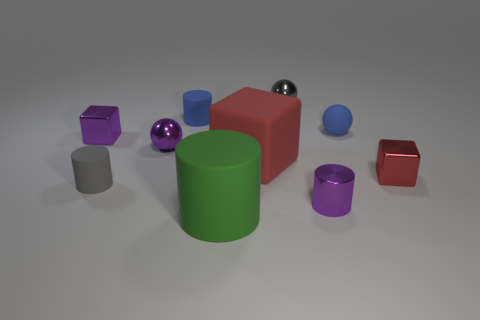What size is the metal ball behind the tiny purple metallic cube?
Your response must be concise. Small. What is the shape of the small matte object in front of the small metallic block that is on the right side of the big red block?
Provide a succinct answer. Cylinder. What number of tiny matte things are to the left of the small sphere to the left of the tiny blue object behind the small blue rubber sphere?
Give a very brief answer. 1. Are there fewer tiny matte balls that are to the left of the green thing than small red matte spheres?
Offer a very short reply. No. Are there any other things that are the same shape as the large red rubber thing?
Your response must be concise. Yes. There is a tiny matte object that is left of the small blue matte cylinder; what is its shape?
Provide a short and direct response. Cylinder. What shape is the red object behind the tiny block to the right of the purple metal object in front of the small gray rubber cylinder?
Provide a short and direct response. Cube. How many things are either small blue objects or shiny cylinders?
Provide a succinct answer. 3. There is a purple metallic thing that is right of the big green rubber cylinder; is its shape the same as the small purple shiny thing that is left of the gray rubber thing?
Offer a terse response. No. What number of tiny things are to the left of the small purple metallic ball and in front of the tiny red object?
Ensure brevity in your answer.  1. 